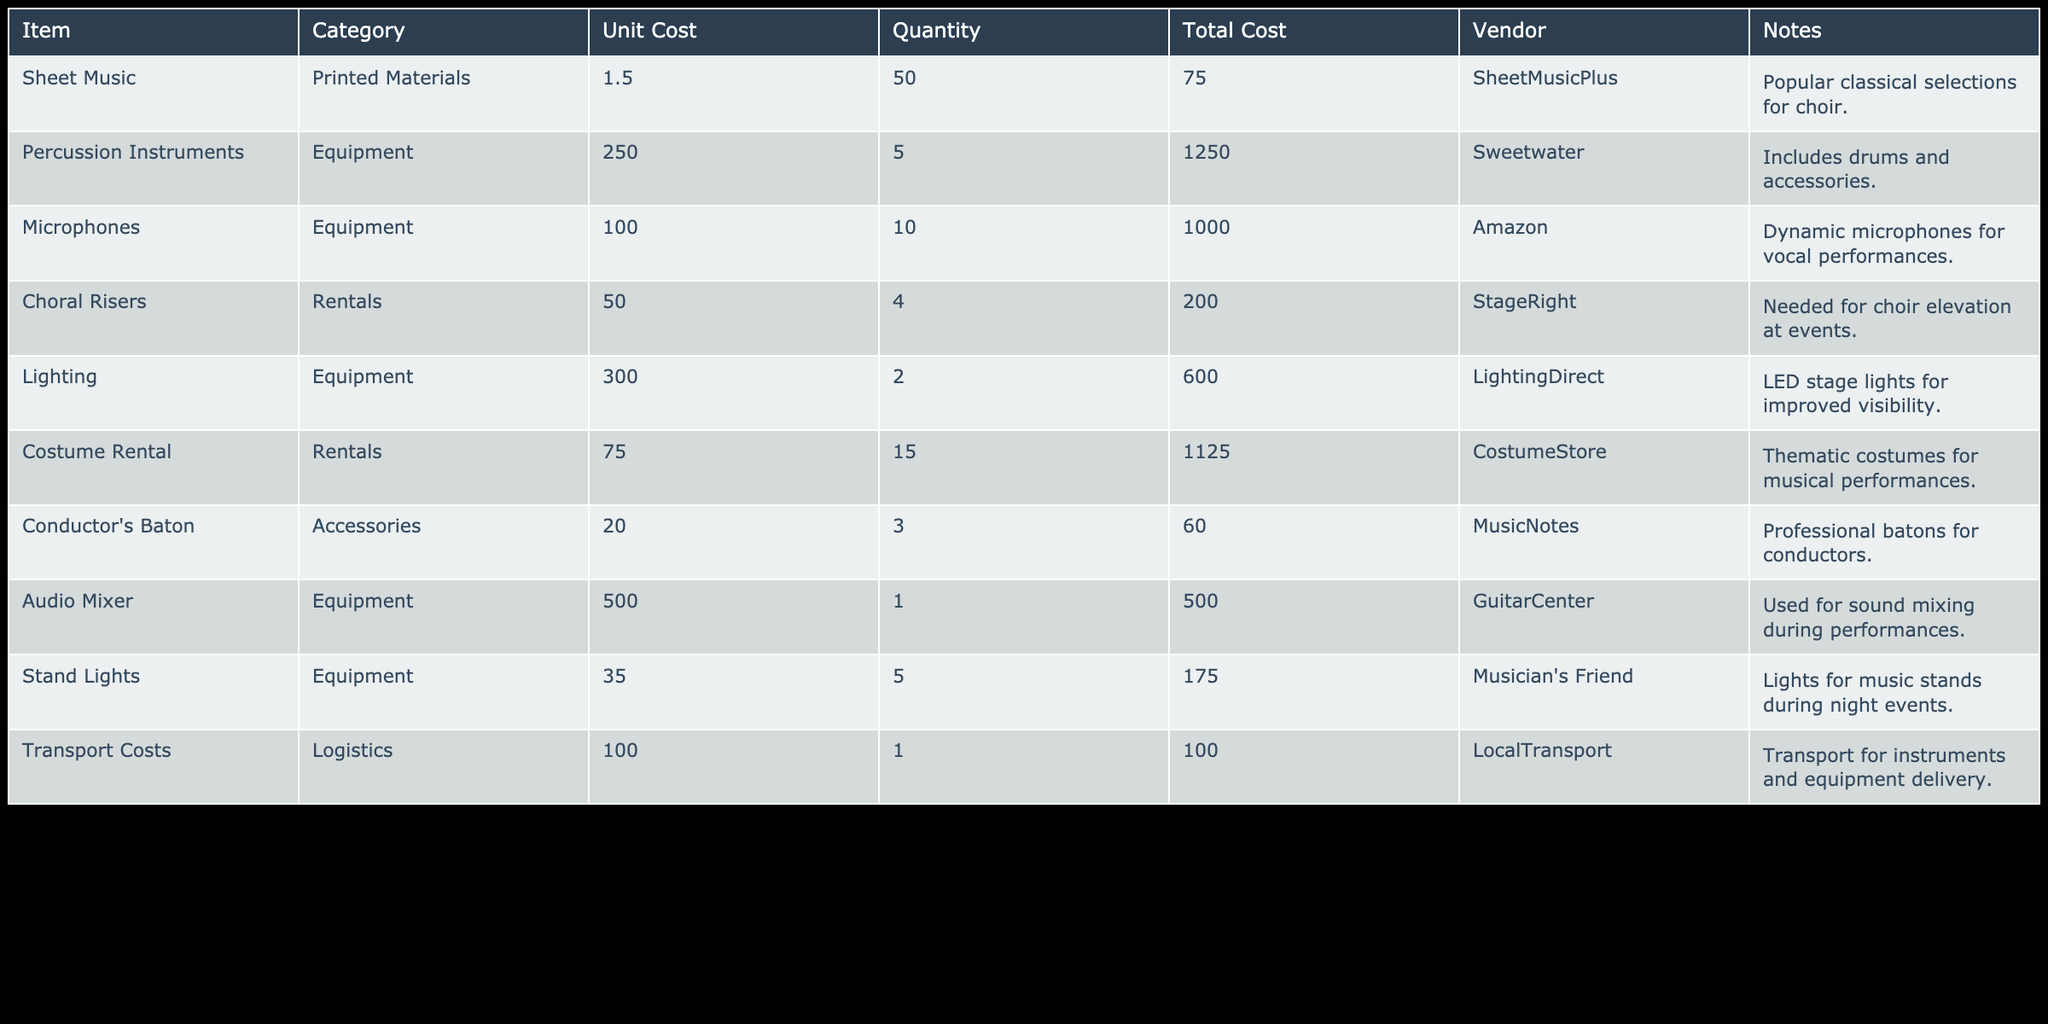What is the total cost of all printed materials? Looking at the category 'Printed Materials,' there is only one item listed: 'Sheet Music' with a total cost of 75.00. Hence, the total cost for printed materials is simply 75.00.
Answer: 75.00 Which equipment item has the highest unit cost? Analyzing the 'Equipment' category, we have Percussion Instruments at a unit cost of 250.00, Microphones at 100.00, Lighting at 300.00, and Audio Mixer at 500.00. The item 'Audio Mixer' holds the highest unit cost at 500.00.
Answer: 500.00 What is the total cost for all rental items? The rental items are 'Choral Risers' at 200.00 and 'Costume Rental' at 1125.00. Adding these together, 200.00 + 1125.00 gives a total of 1325.00 for all rental items.
Answer: 1325.00 Is the total cost for microphones greater than the total cost for costumes? The total cost for 'Microphones' is 1000.00 and for 'Costume Rental' it is 1125.00. Since 1000.00 is not greater than 1125.00, the statement is false.
Answer: No What is the average cost of equipment items listed in the table? The equipment items are: Percussion Instruments (1250.00), Microphones (1000.00), Lighting (600.00), Audio Mixer (500.00), and Stand Lights (175.00). First, sum these costs: 1250.00 + 1000.00 + 600.00 + 500.00 + 175.00 = 3525.00. With 5 items, the average is 3525.00 divided by 5, which equals 705.00.
Answer: 705.00 Are the transport costs less than the total cost of printed materials? The 'Transport Costs' are 100.00 and the 'Total Cost' for 'Sheet Music' (the only printed material) is 75.00. Since 100.00 is greater than 75.00, the statement is false.
Answer: No What is the total cost for all items categorized as accessories? The only item in the 'Accessories' category is the 'Conductor's Baton' costing 60.00. Since there are no other accessory items, the total cost remains 60.00.
Answer: 60.00 What is the total amount spent on all supplies and equipment? To find the total, we sum all the total costs of each item: 75.00 (Sheet Music) + 1250.00 (Percussion Instruments) + 1000.00 (Microphones) + 200.00 (Choral Risers) + 600.00 (Lighting) + 1125.00 (Costume Rental) + 60.00 (Conductor's Baton) + 500.00 (Audio Mixer) + 175.00 (Stand Lights) + 100.00 (Transport Costs). Adding these gives us 3890.00.
Answer: 3890.00 